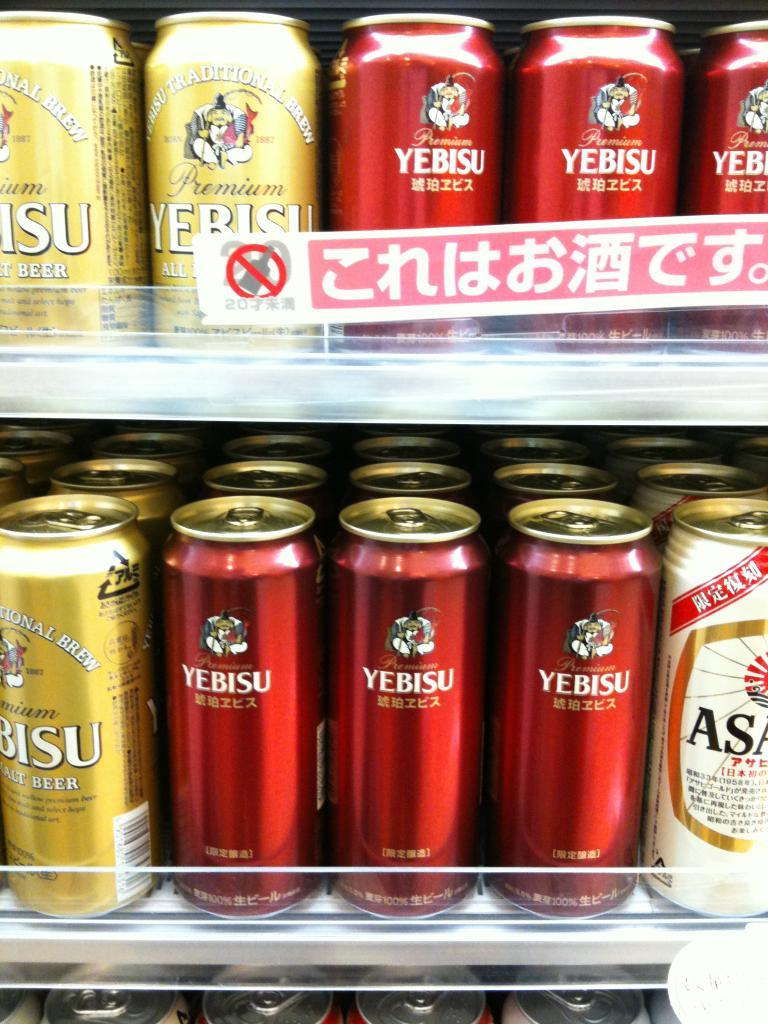<image>
Create a compact narrative representing the image presented. Cans of Yebisu, some gold and some red, are lined up on shelves. 